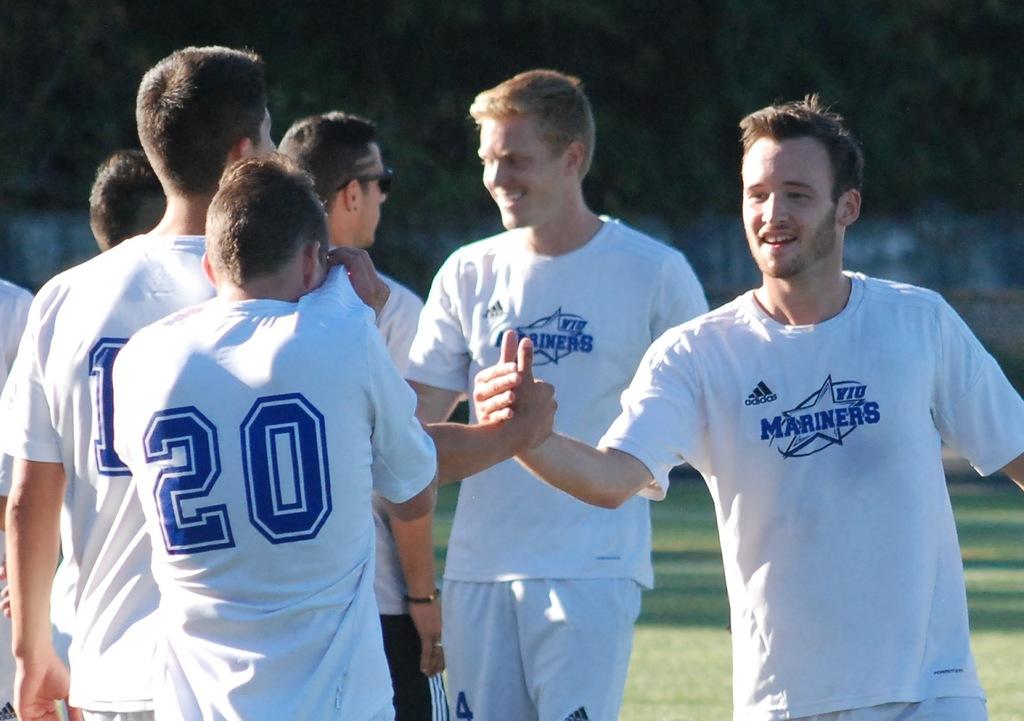What is the name of the team?
Your response must be concise. Mariners. What number can we see on the players jersey?
Your response must be concise. 20. 